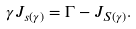Convert formula to latex. <formula><loc_0><loc_0><loc_500><loc_500>\gamma J _ { s ( \gamma ) } = \Gamma - J _ { S ( \gamma ) } .</formula> 